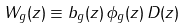<formula> <loc_0><loc_0><loc_500><loc_500>W _ { g } ( z ) \equiv b _ { g } ( z ) \, \phi _ { g } ( z ) \, D ( z )</formula> 